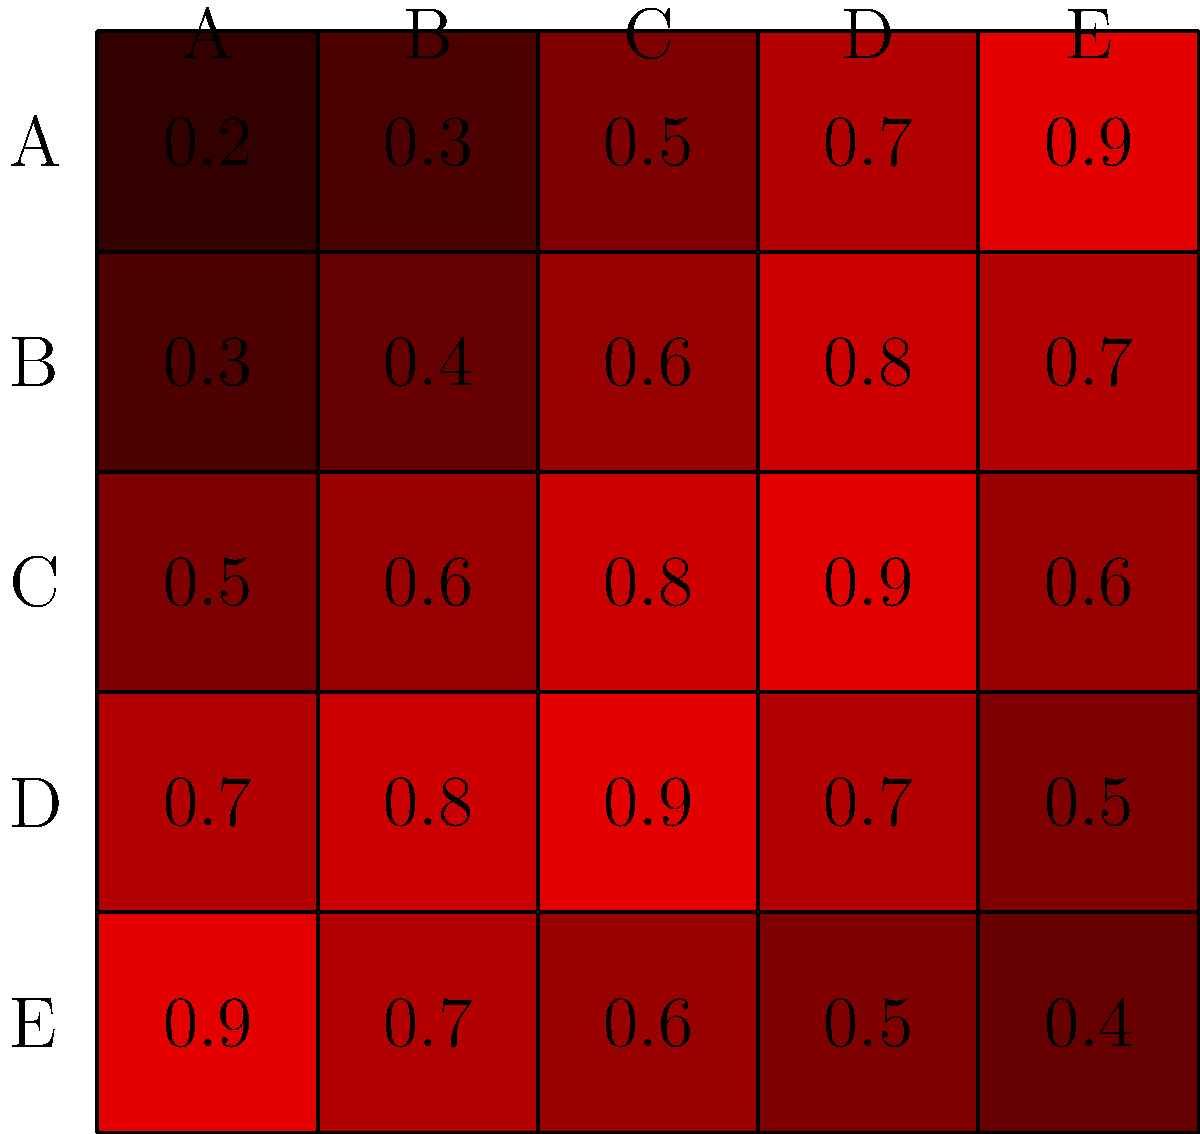As a school counselor analyzing classroom interactions, you're presented with a heatmap showing the frequency of interactions between students A, B, C, D, and E. Darker red indicates more frequent interactions. Based on this heatmap, which student appears to be the most socially isolated? To determine which student is the most socially isolated, we need to analyze the interaction patterns for each student:

1. Look at the row and column for each student:
   - Student A: High interaction with E, moderate with D, lower with others
   - Student B: Moderate interactions overall, highest with D
   - Student C: High interactions with B, C, and D
   - Student D: High interactions with B and C
   - Student E: High interaction with A, lower with others

2. Compare the overall interaction levels:
   - A has one strong connection (E) but lower interactions with others
   - B has moderate interactions across the board
   - C has multiple strong connections
   - D has multiple strong connections
   - E has one strong connection (A) but lower interactions with others

3. Identify the student with the least overall interactions:
   - E shows the lowest overall interaction pattern, with only one strong connection to A (0.9) and significantly lower interactions with others (0.7, 0.6, 0.5, 0.4)

4. Consider the implications of isolation:
   - E's interaction pattern suggests they mainly interact with A and have limited engagement with other students, indicating potential social isolation.
Answer: Student E 